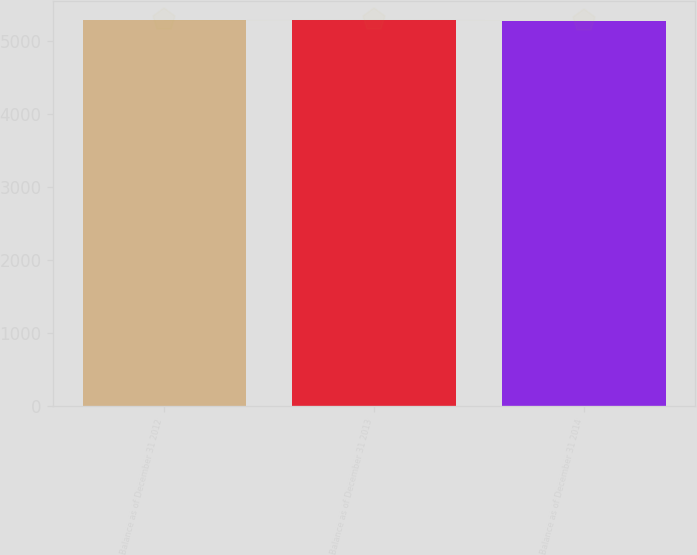Convert chart to OTSL. <chart><loc_0><loc_0><loc_500><loc_500><bar_chart><fcel>Balance as of December 31 2012<fcel>Balance as of December 31 2013<fcel>Balance as of December 31 2014<nl><fcel>5287<fcel>5294<fcel>5286<nl></chart> 